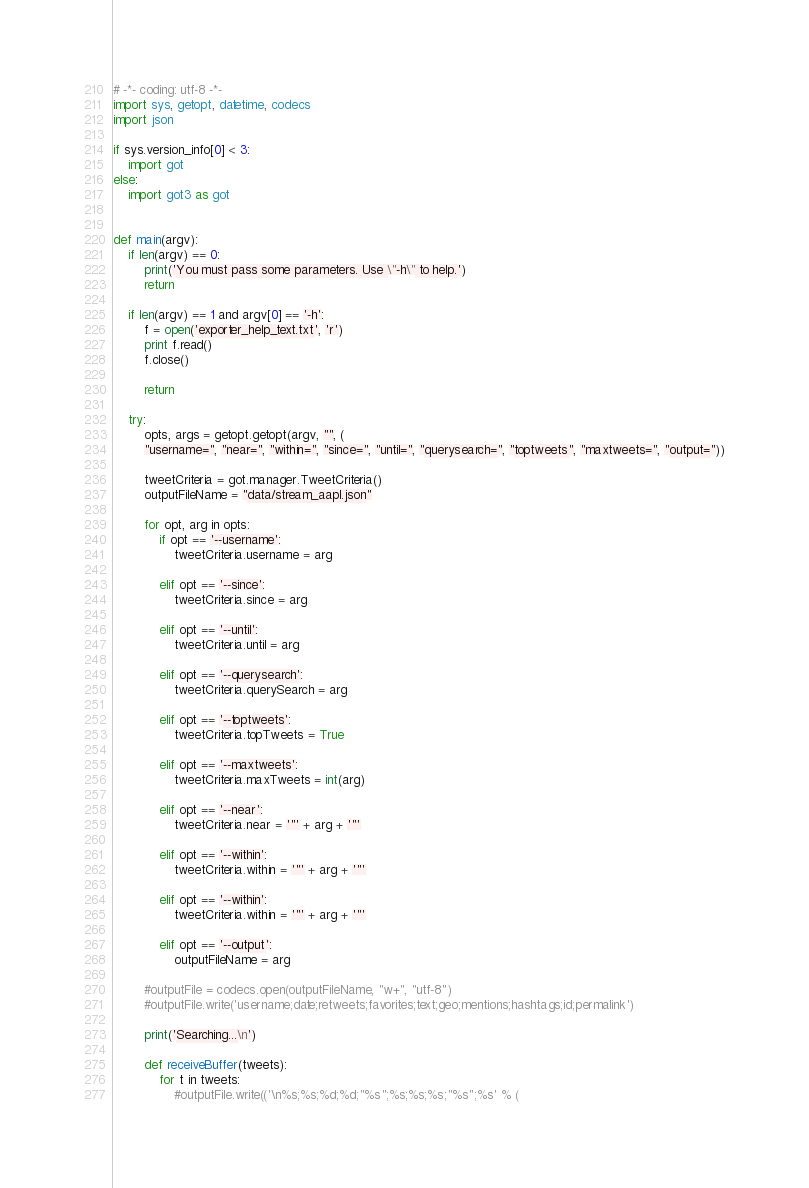<code> <loc_0><loc_0><loc_500><loc_500><_Python_># -*- coding: utf-8 -*-
import sys, getopt, datetime, codecs
import json

if sys.version_info[0] < 3:
    import got
else:
    import got3 as got


def main(argv):
    if len(argv) == 0:
        print('You must pass some parameters. Use \"-h\" to help.')
        return

    if len(argv) == 1 and argv[0] == '-h':
        f = open('exporter_help_text.txt', 'r')
        print f.read()
        f.close()

        return

    try:
        opts, args = getopt.getopt(argv, "", (
        "username=", "near=", "within=", "since=", "until=", "querysearch=", "toptweets", "maxtweets=", "output="))

        tweetCriteria = got.manager.TweetCriteria()
        outputFileName = "data/stream_aapl.json"

        for opt, arg in opts:
            if opt == '--username':
                tweetCriteria.username = arg

            elif opt == '--since':
                tweetCriteria.since = arg

            elif opt == '--until':
                tweetCriteria.until = arg

            elif opt == '--querysearch':
                tweetCriteria.querySearch = arg

            elif opt == '--toptweets':
                tweetCriteria.topTweets = True

            elif opt == '--maxtweets':
                tweetCriteria.maxTweets = int(arg)

            elif opt == '--near':
                tweetCriteria.near = '"' + arg + '"'

            elif opt == '--within':
                tweetCriteria.within = '"' + arg + '"'

            elif opt == '--within':
                tweetCriteria.within = '"' + arg + '"'

            elif opt == '--output':
                outputFileName = arg

        #outputFile = codecs.open(outputFileName, "w+", "utf-8")
        #outputFile.write('username;date;retweets;favorites;text;geo;mentions;hashtags;id;permalink')

        print('Searching...\n')

        def receiveBuffer(tweets):
            for t in tweets:
                #outputFile.write(('\n%s;%s;%d;%d;"%s";%s;%s;%s;"%s";%s' % (</code> 